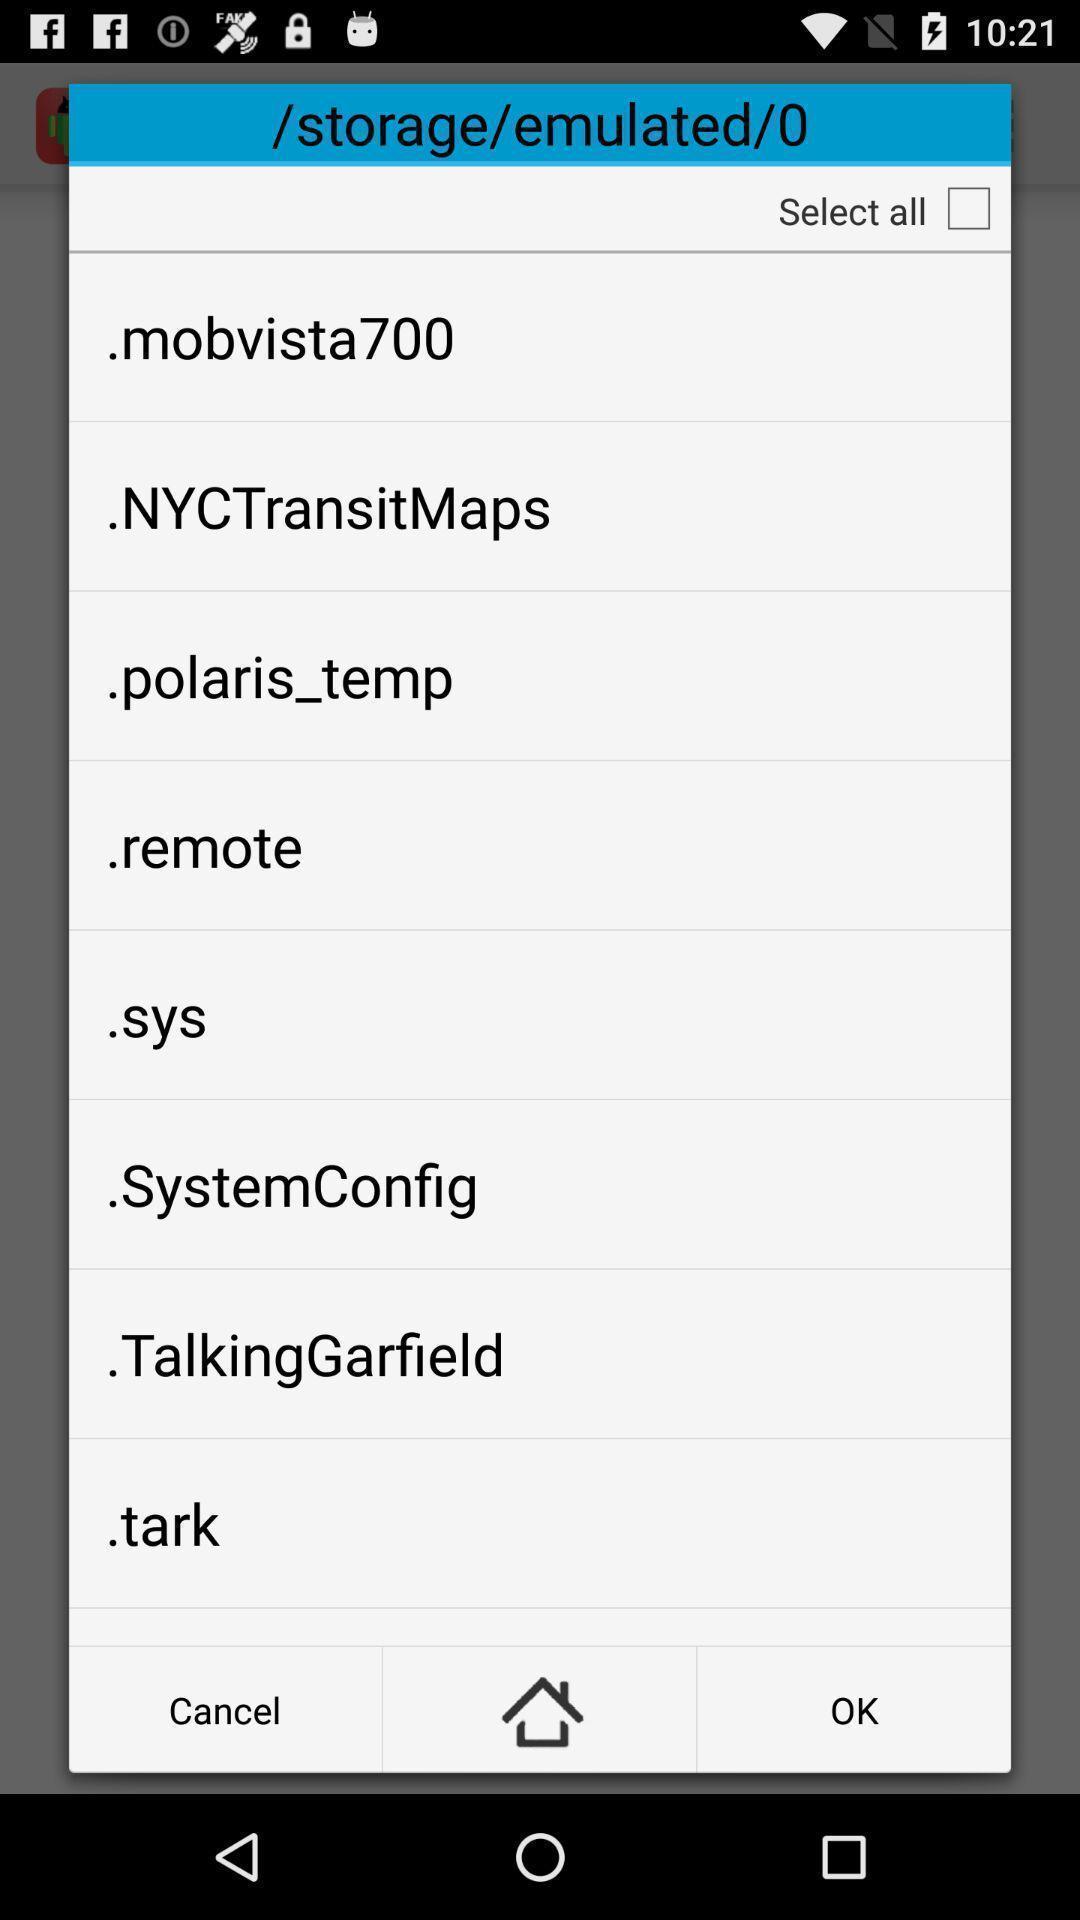Describe the visual elements of this screenshot. Pop-up to select an option among the available list. 